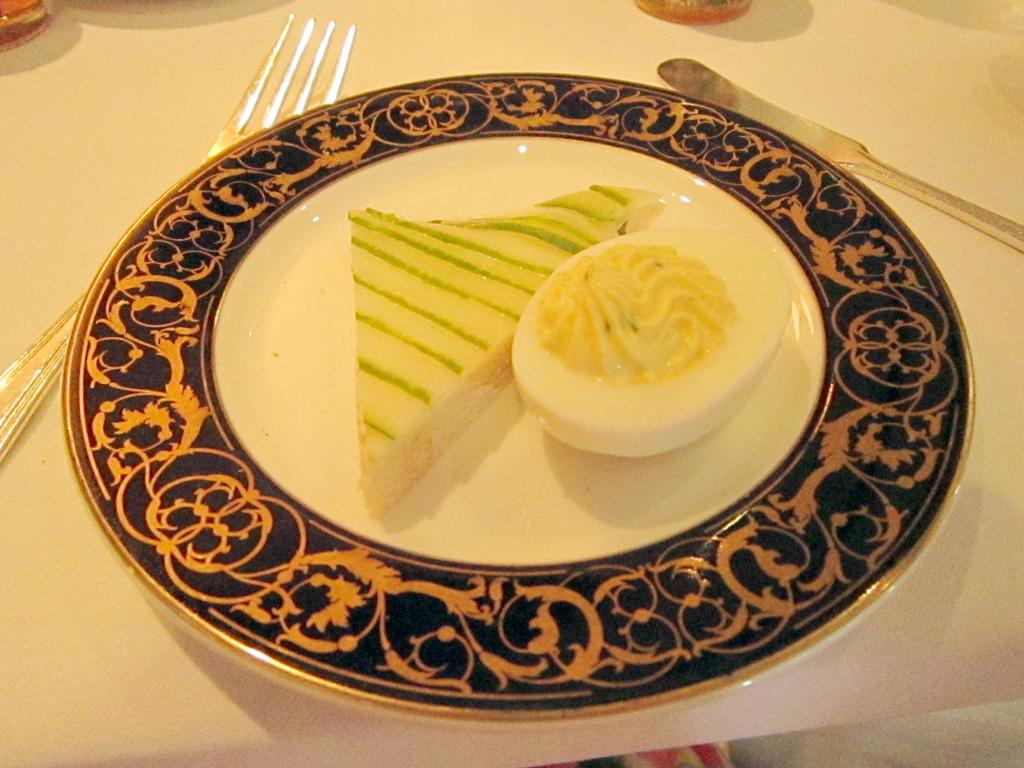What piece of furniture is present in the image? There is a table in the image. What is placed on the table? There is a plate on the table. What food items are on the plate? The plate contains a sandwich and an egg slice. What utensils are on the table? There is a fork and a knife on the table. What type of guitar can be heard playing in the background of the image? There is no guitar or any sound present in the image; it is a still image of a table with a plate and utensils. 